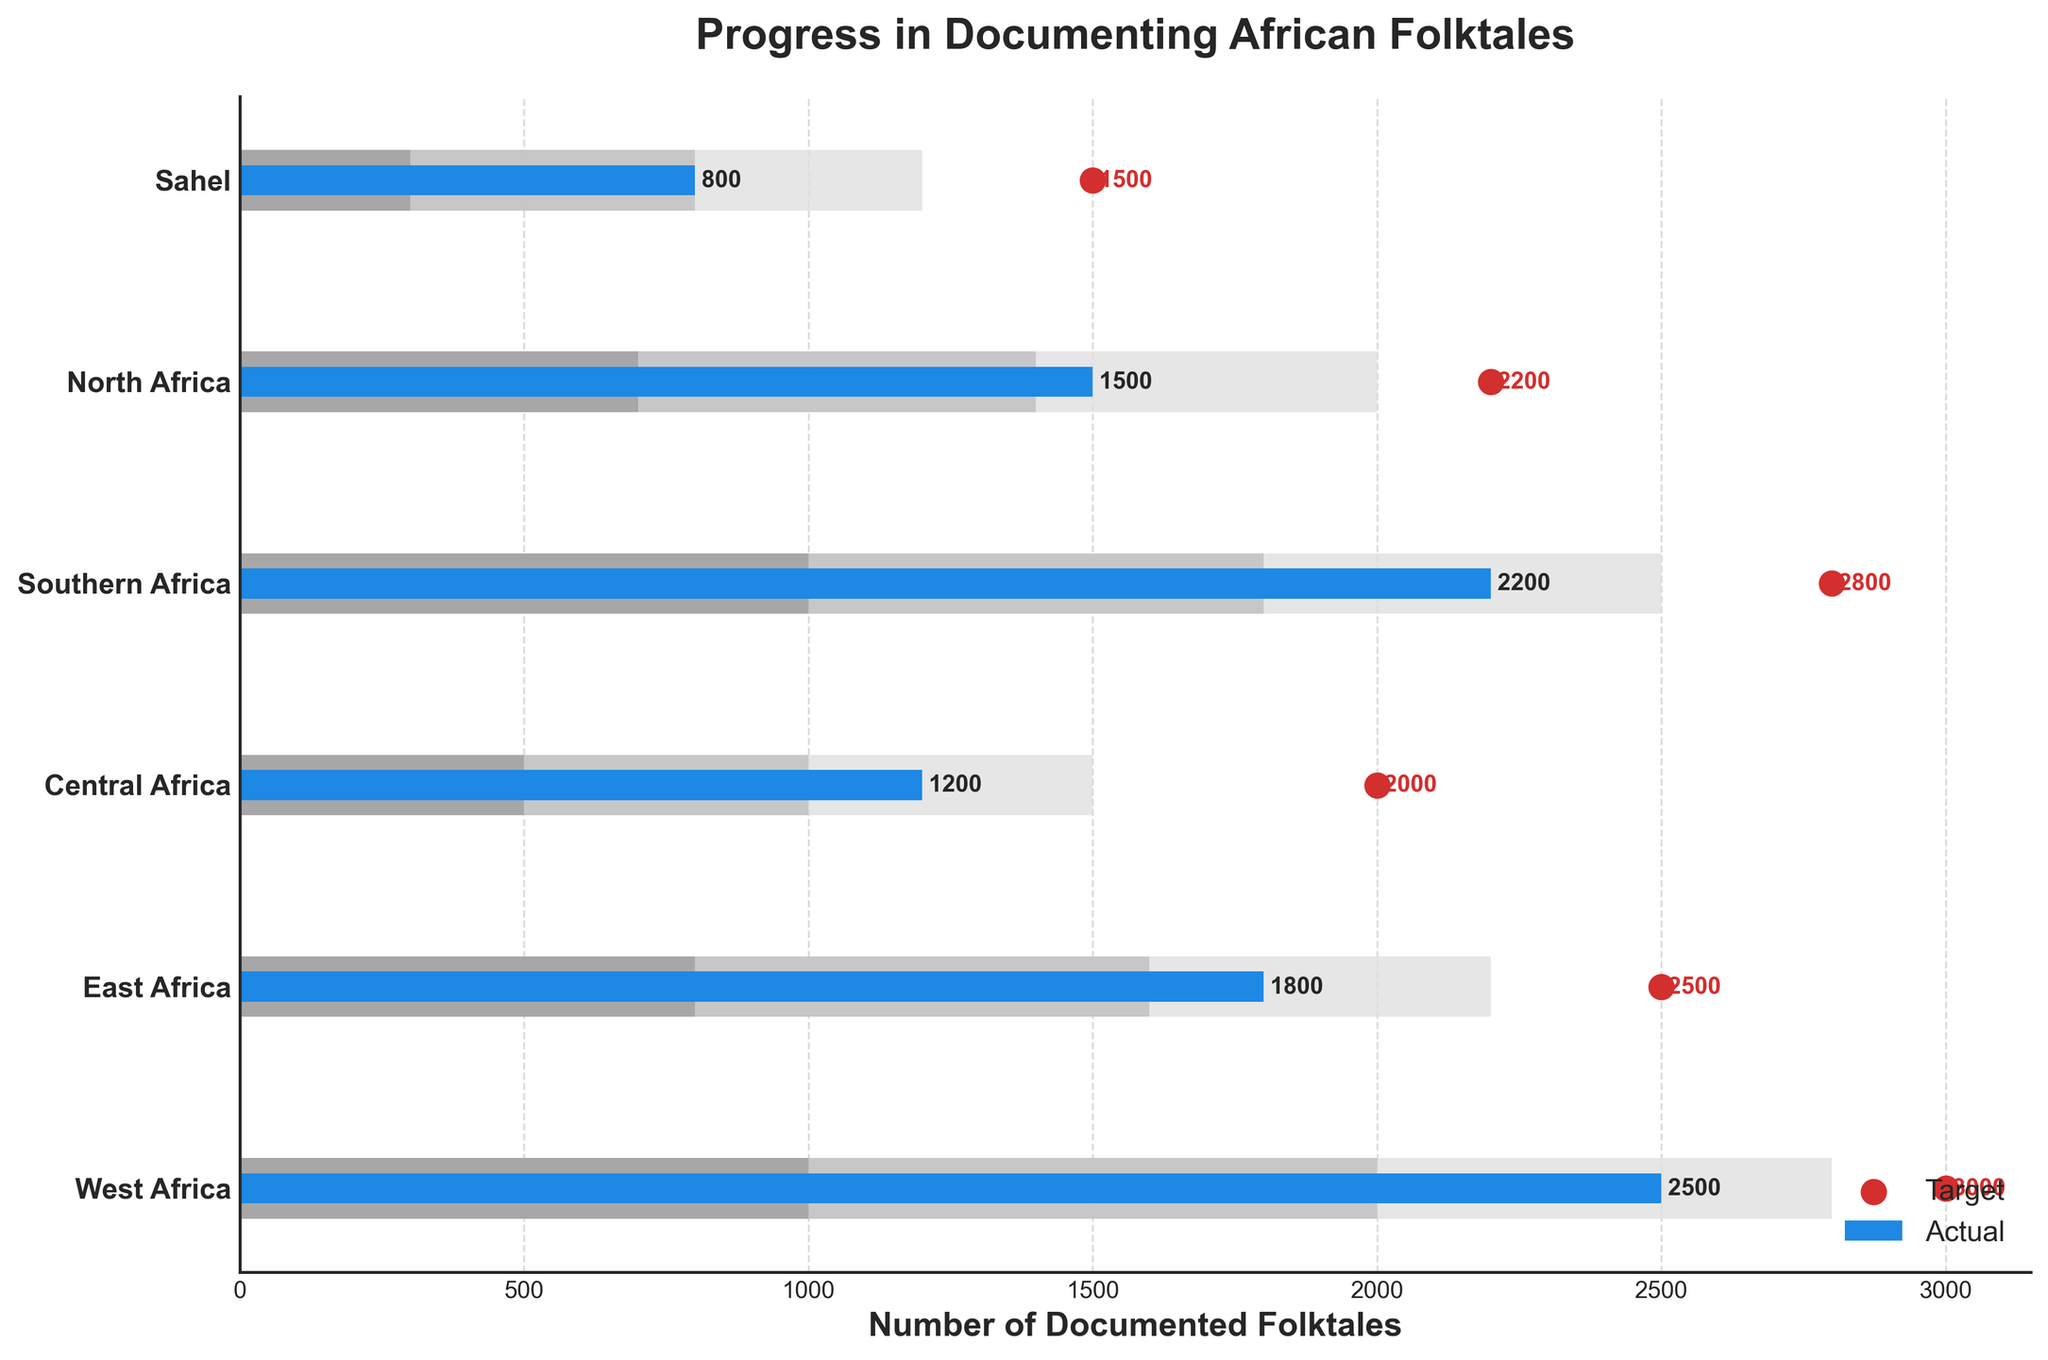What is the title of the chart? The title can be found at the top of the chart in larger and bold font.
Answer: Progress in Documenting African Folktales Which region has the highest number of actual documented folktales? Look at the longest bar that represents the actual values on the y-axis.
Answer: West Africa How many documented folktales are targeted in North Africa? Check the target value marked with a red dot for the North Africa region.
Answer: 2200 What is the difference between the target and actual numbers of documented folktales in East Africa? Subtract the actual number from the target number for East Africa. (2500 - 1800).
Answer: 700 Which regions have met their documented folktales target? Compare actual and target values; regions where the actual value is equal to or greater than the target have met the target.
Answer: None What is the range for the second tier in terms of documented folktales for Central Africa? Refer to the lighter shade bar representing the second range for Central Africa.
Answer: 1000 Which region has achieved the closest to its target number of documented folktales? Calculate the differences between actual and target for each region and find the smallest difference. West Africa: 3000-2500=500, East Africa: 2500-1800=700, Central Africa: 2000-1200=800, Southern Africa: 2800-2200=600, North Africa: 2200-1500=700, Sahel: 1500-800=700.
Answer: West Africa How many regions have an actual documented folktales number below 2000? Count the regions that have an actual value less than 2000 by looking at their respective bars. Central Africa (1200), North Africa (1500), Sahel (800).
Answer: 3 Which region's actual documented folktales are in the lowest range as defined by the chart? Identify the region where the actual value is within the lowest range bar.
Answer: Sahel By how much does Southern Africa exceed its first range of documented folktales? Find the difference between the actual value and the boundary of the first range for Southern Africa. (2200 - 1000).
Answer: 1200 